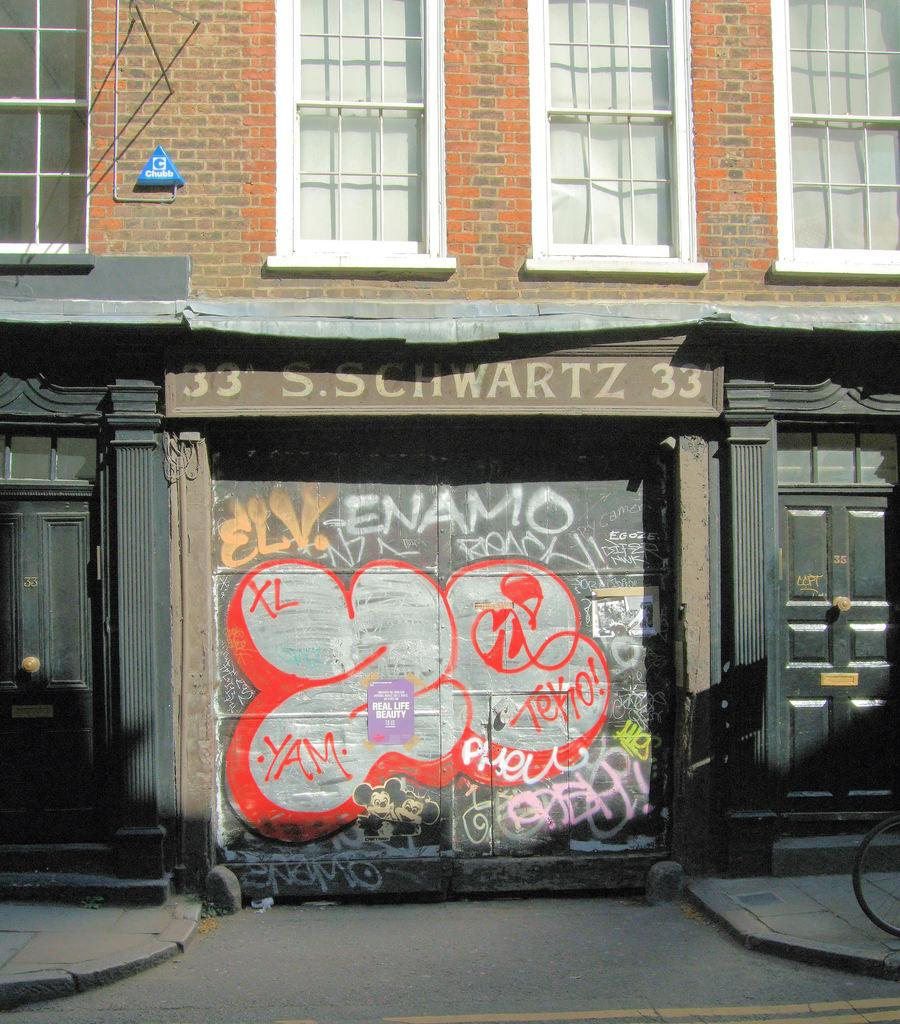What type of structure is present in the image? There is a building in the image. What feature can be seen on the building? The building has windows. What is the color of the windows? The windows are white in color. What is the color of the doors of the building? The doors of the building are black in color. What is the chance of finding an arch in the building in the image? There is no mention of an arch in the building in the image, so it cannot be determined from the provided facts. 